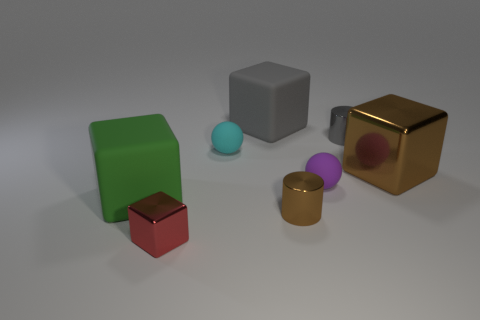Subtract all cyan blocks. Subtract all blue cylinders. How many blocks are left? 4 Add 2 cyan objects. How many objects exist? 10 Subtract all spheres. How many objects are left? 6 Add 4 large metallic blocks. How many large metallic blocks are left? 5 Add 1 big cyan matte cylinders. How many big cyan matte cylinders exist? 1 Subtract 1 purple spheres. How many objects are left? 7 Subtract all brown metal cylinders. Subtract all gray rubber things. How many objects are left? 6 